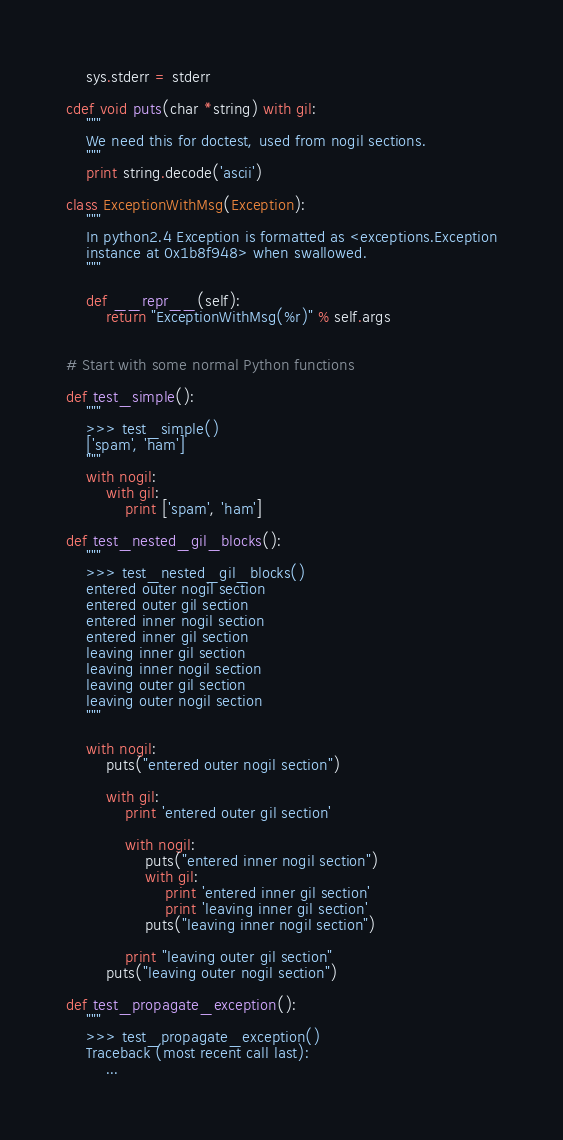Convert code to text. <code><loc_0><loc_0><loc_500><loc_500><_Cython_>    sys.stderr = stderr

cdef void puts(char *string) with gil:
    """
    We need this for doctest, used from nogil sections.
    """
    print string.decode('ascii')

class ExceptionWithMsg(Exception):
    """
    In python2.4 Exception is formatted as <exceptions.Exception
    instance at 0x1b8f948> when swallowed.
    """

    def __repr__(self):
        return "ExceptionWithMsg(%r)" % self.args


# Start with some normal Python functions

def test_simple():
    """
    >>> test_simple()
    ['spam', 'ham']
    """
    with nogil:
        with gil:
            print ['spam', 'ham']

def test_nested_gil_blocks():
    """
    >>> test_nested_gil_blocks()
    entered outer nogil section
    entered outer gil section
    entered inner nogil section
    entered inner gil section
    leaving inner gil section
    leaving inner nogil section
    leaving outer gil section
    leaving outer nogil section
    """

    with nogil:
        puts("entered outer nogil section")

        with gil:
            print 'entered outer gil section'

            with nogil:
                puts("entered inner nogil section")
                with gil:
                    print 'entered inner gil section'
                    print 'leaving inner gil section'
                puts("leaving inner nogil section")

            print "leaving outer gil section"
        puts("leaving outer nogil section")

def test_propagate_exception():
    """
    >>> test_propagate_exception()
    Traceback (most recent call last):
        ...</code> 